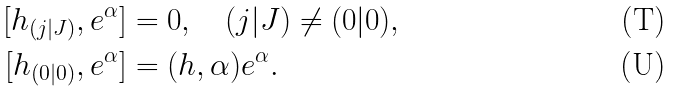<formula> <loc_0><loc_0><loc_500><loc_500>{ [ h _ { ( j | J ) } } , e ^ { \alpha } ] & = 0 , \quad ( j | J ) \neq ( 0 | 0 ) , \\ { [ h _ { ( 0 | 0 ) } } , e ^ { \alpha } ] & = ( h , \alpha ) e ^ { \alpha } .</formula> 